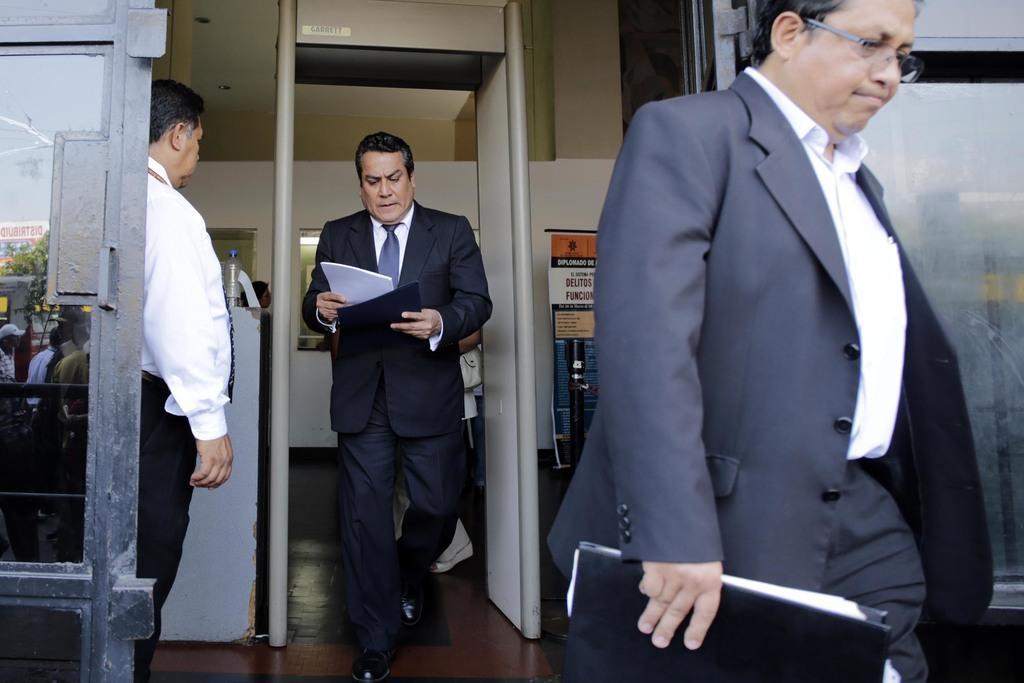Please provide a concise description of this image. In this image I can see three man and I can see all of them are wearing formal dress. I can also see two of them are holding files and papers. In the background I can see few boards, a bottle and on these boards I can see something is written. On the left side of this image I can see a door and on it I can see reflection of people, a tree and few other things. 